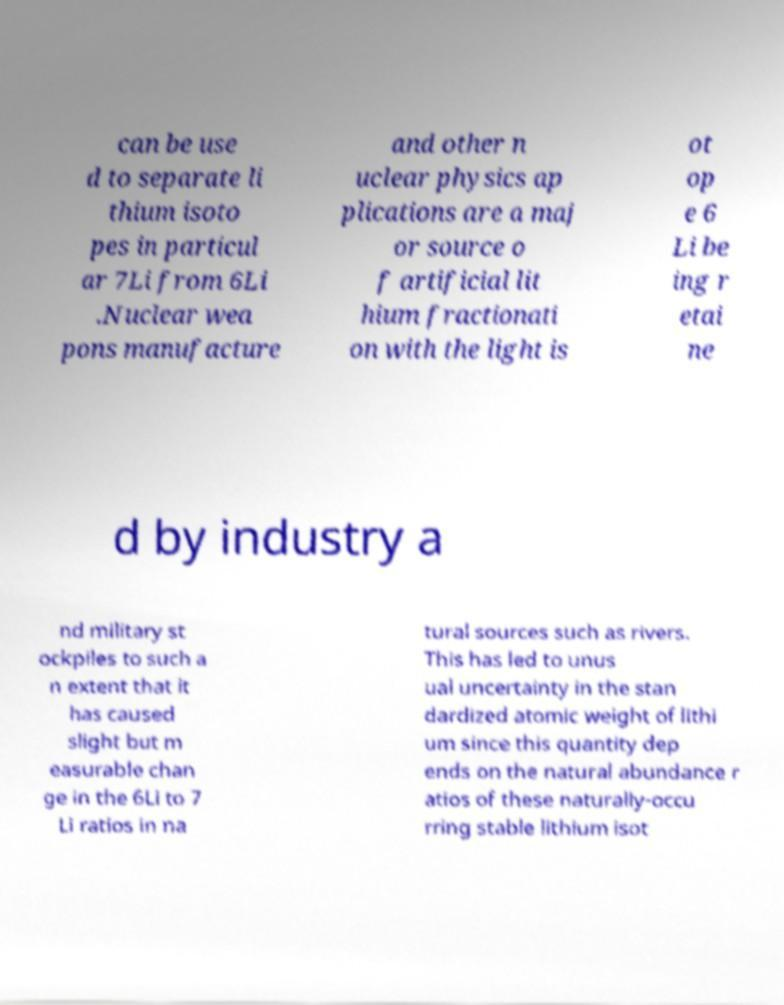Please read and relay the text visible in this image. What does it say? can be use d to separate li thium isoto pes in particul ar 7Li from 6Li .Nuclear wea pons manufacture and other n uclear physics ap plications are a maj or source o f artificial lit hium fractionati on with the light is ot op e 6 Li be ing r etai ne d by industry a nd military st ockpiles to such a n extent that it has caused slight but m easurable chan ge in the 6Li to 7 Li ratios in na tural sources such as rivers. This has led to unus ual uncertainty in the stan dardized atomic weight of lithi um since this quantity dep ends on the natural abundance r atios of these naturally-occu rring stable lithium isot 